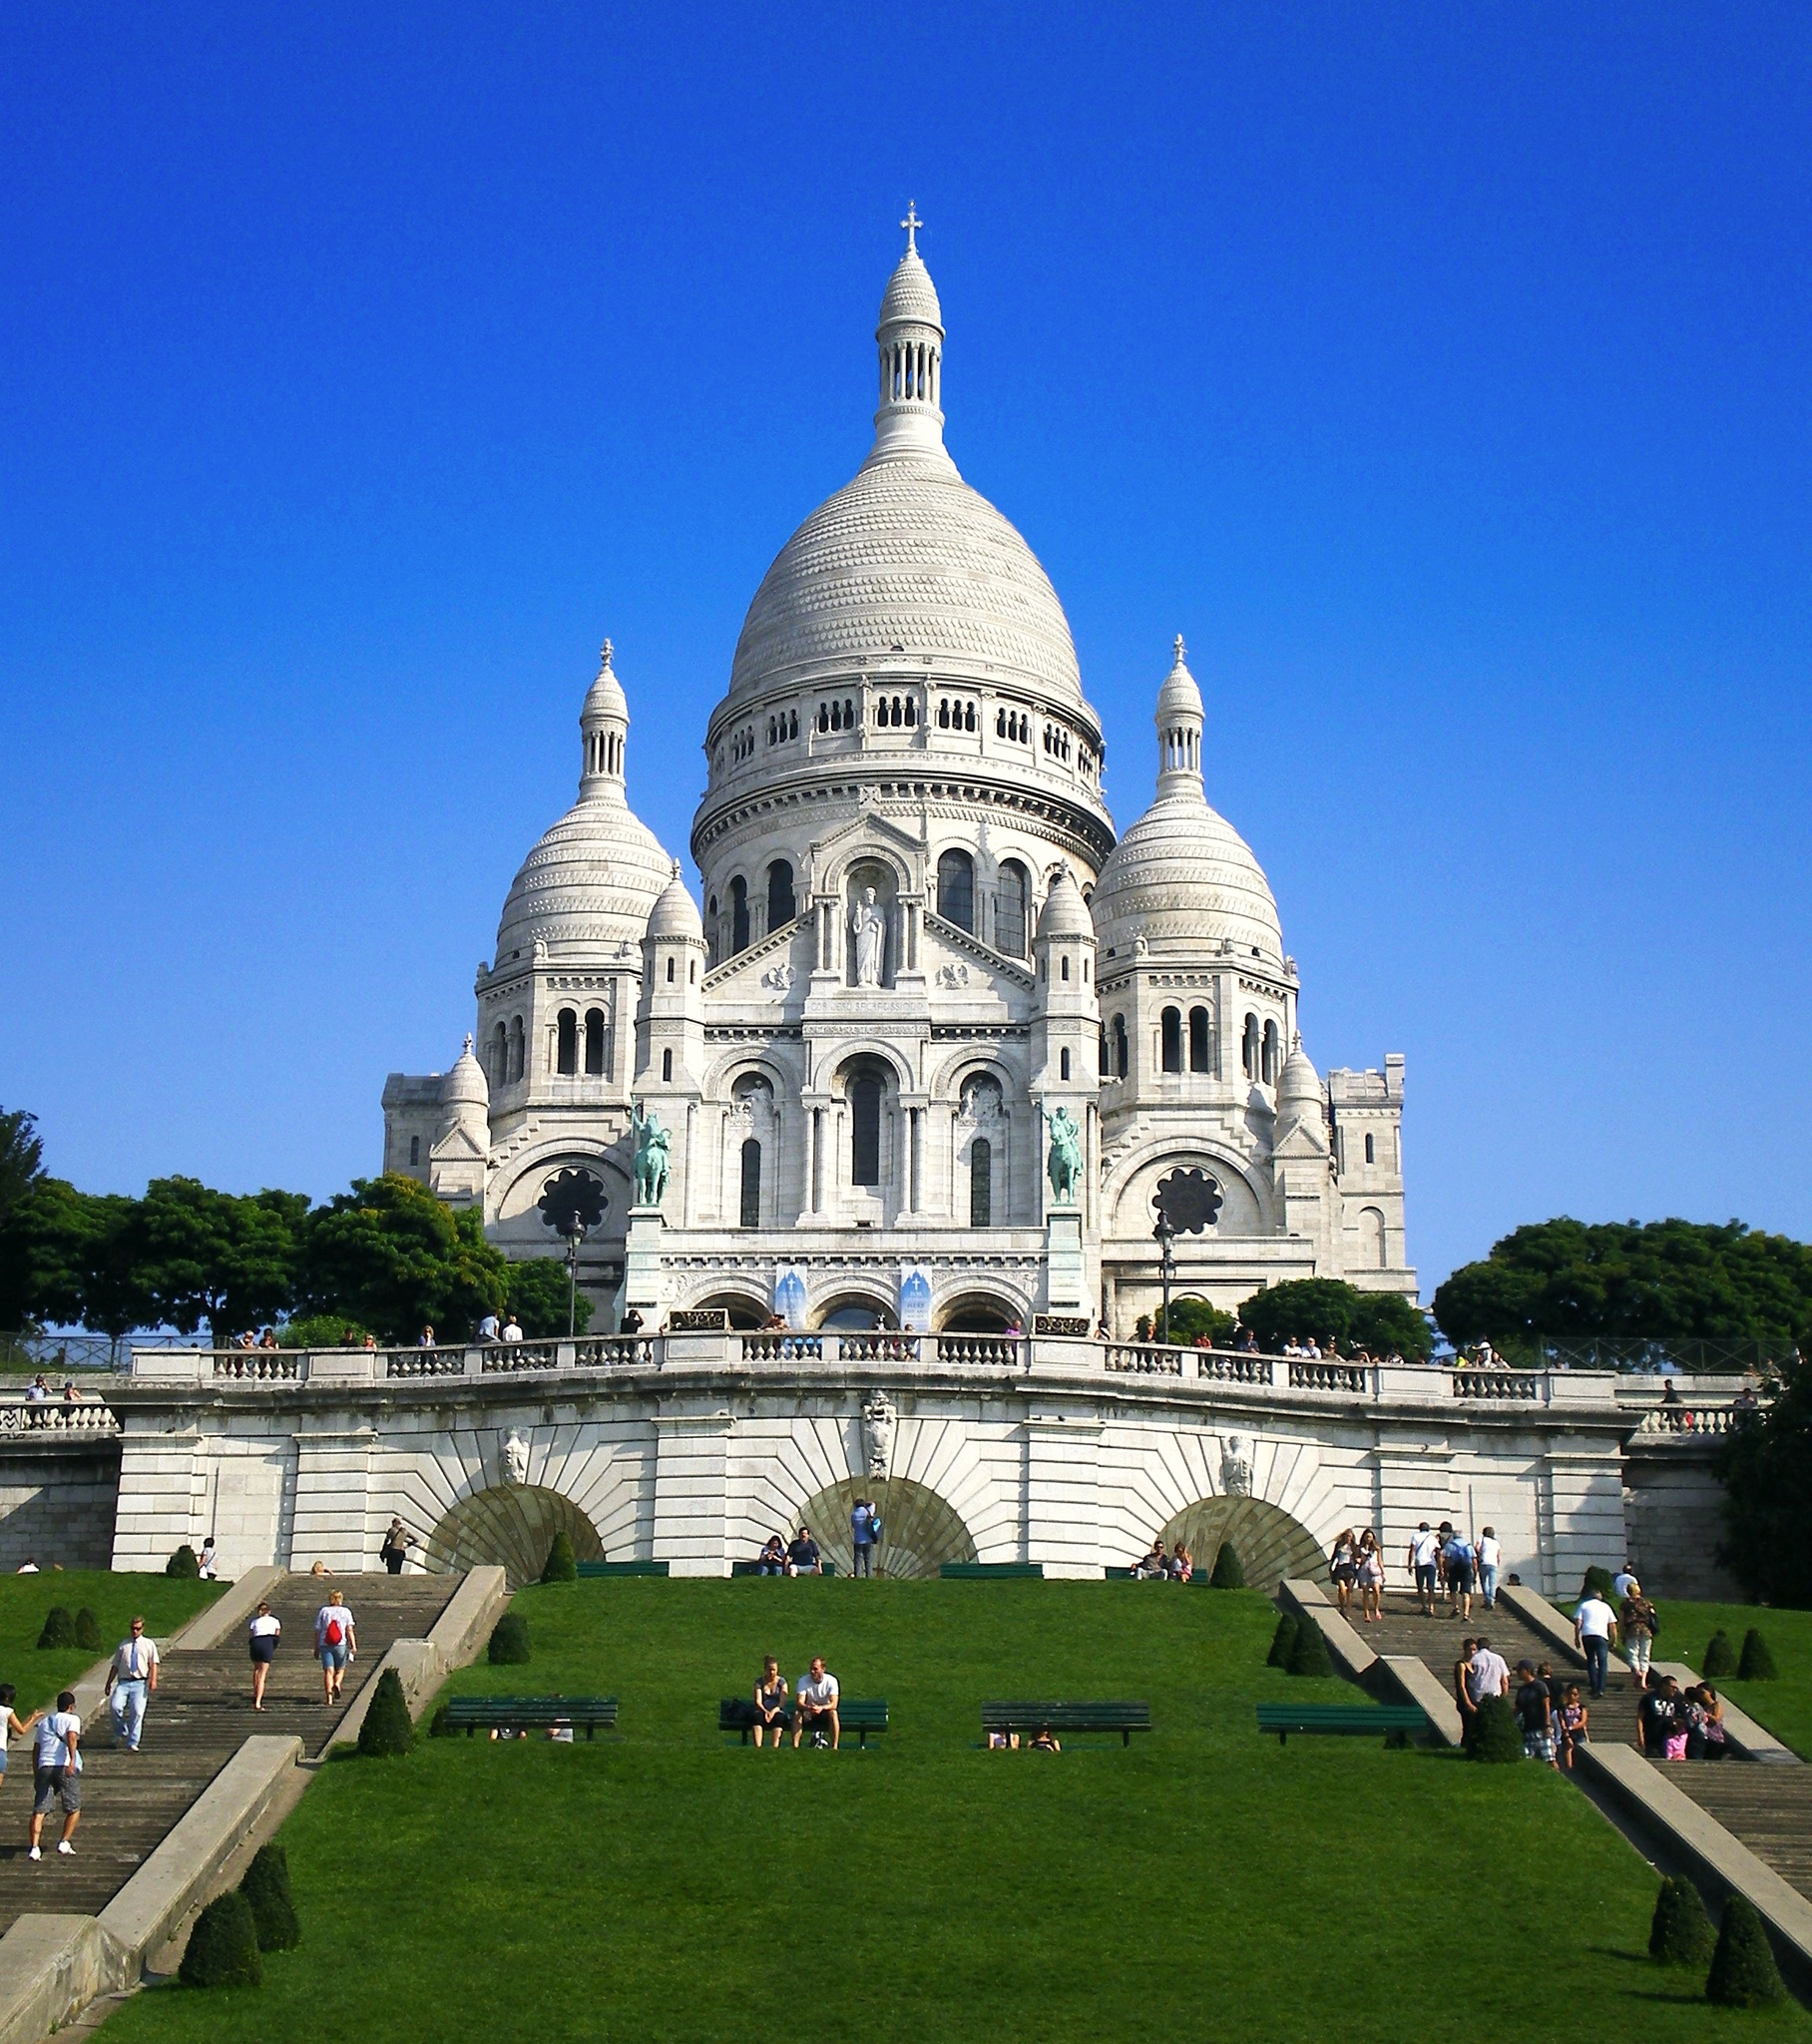Can you explain the architectural significance of the Sacré-Cœur? Certainly, the Sacré-Cœur Basilica is a splendid example of Romano-Byzantine architecture, a style chosen to counteract the modernist trends of the time. Its white stones, which exude calcite, ensure that the basilica remains brilliantly white even with weathering and pollution. The triple-arched portico and the bronze equestrian statue of King Saint Louis over the portico, emphasize its majestic aura. The large central dome is capped by a colossal lantern tower that serves as a beacon of hope, visible from miles away across Paris. 